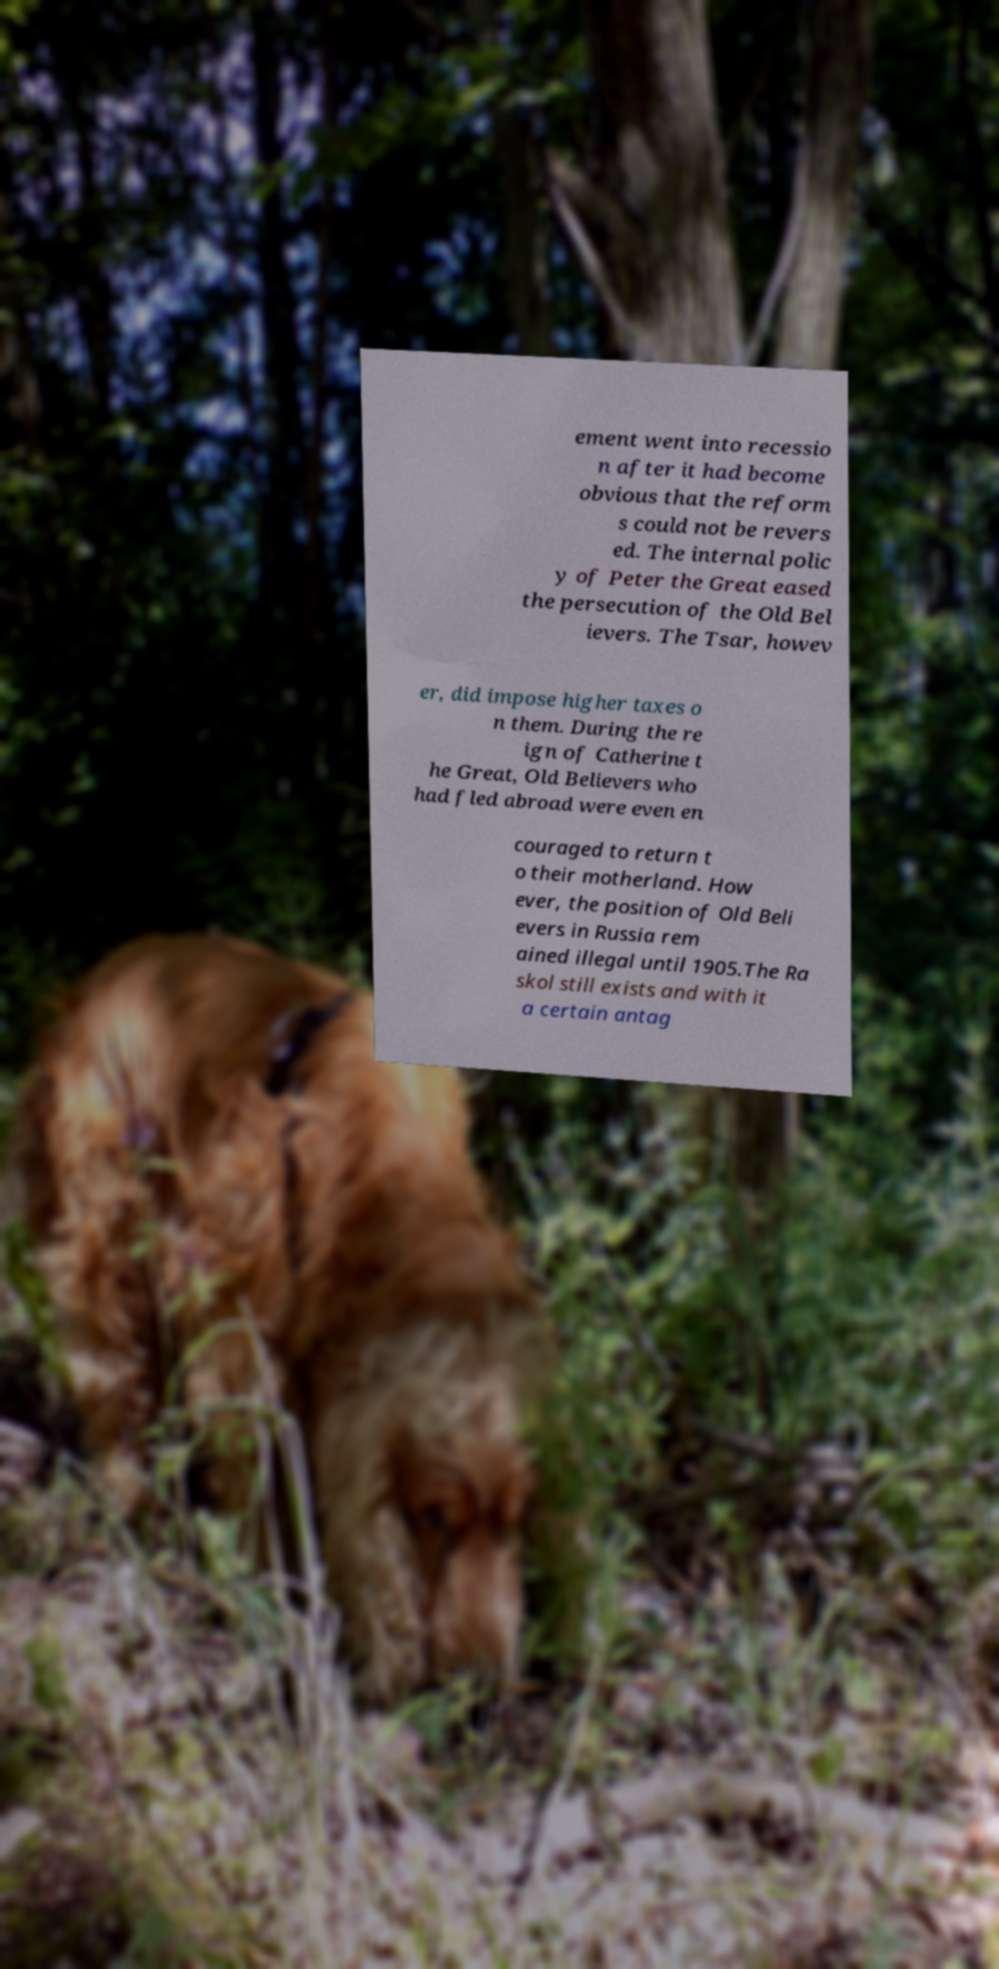Please read and relay the text visible in this image. What does it say? ement went into recessio n after it had become obvious that the reform s could not be revers ed. The internal polic y of Peter the Great eased the persecution of the Old Bel ievers. The Tsar, howev er, did impose higher taxes o n them. During the re ign of Catherine t he Great, Old Believers who had fled abroad were even en couraged to return t o their motherland. How ever, the position of Old Beli evers in Russia rem ained illegal until 1905.The Ra skol still exists and with it a certain antag 